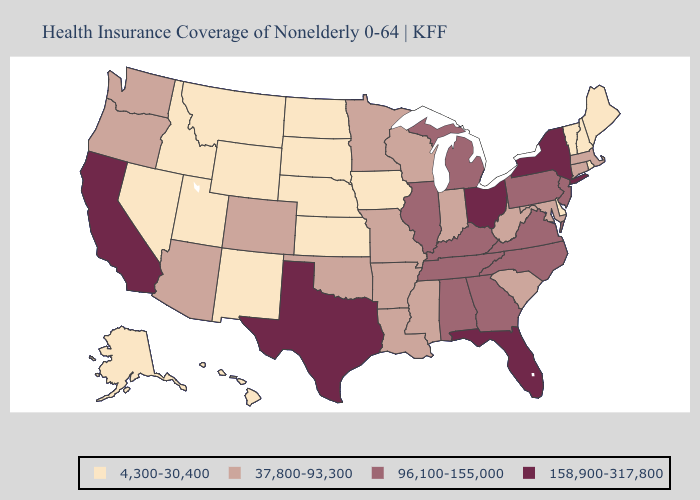Which states have the highest value in the USA?
Concise answer only. California, Florida, New York, Ohio, Texas. Which states have the highest value in the USA?
Keep it brief. California, Florida, New York, Ohio, Texas. What is the lowest value in states that border Minnesota?
Short answer required. 4,300-30,400. What is the lowest value in the Northeast?
Short answer required. 4,300-30,400. Name the states that have a value in the range 158,900-317,800?
Answer briefly. California, Florida, New York, Ohio, Texas. Does Arizona have the lowest value in the West?
Write a very short answer. No. Name the states that have a value in the range 37,800-93,300?
Concise answer only. Arizona, Arkansas, Colorado, Connecticut, Indiana, Louisiana, Maryland, Massachusetts, Minnesota, Mississippi, Missouri, Oklahoma, Oregon, South Carolina, Washington, West Virginia, Wisconsin. What is the value of Ohio?
Write a very short answer. 158,900-317,800. Does North Dakota have a higher value than New Hampshire?
Quick response, please. No. Does Iowa have the same value as Kansas?
Keep it brief. Yes. What is the value of Arizona?
Give a very brief answer. 37,800-93,300. What is the value of Hawaii?
Write a very short answer. 4,300-30,400. Name the states that have a value in the range 37,800-93,300?
Quick response, please. Arizona, Arkansas, Colorado, Connecticut, Indiana, Louisiana, Maryland, Massachusetts, Minnesota, Mississippi, Missouri, Oklahoma, Oregon, South Carolina, Washington, West Virginia, Wisconsin. Name the states that have a value in the range 4,300-30,400?
Keep it brief. Alaska, Delaware, Hawaii, Idaho, Iowa, Kansas, Maine, Montana, Nebraska, Nevada, New Hampshire, New Mexico, North Dakota, Rhode Island, South Dakota, Utah, Vermont, Wyoming. Name the states that have a value in the range 4,300-30,400?
Keep it brief. Alaska, Delaware, Hawaii, Idaho, Iowa, Kansas, Maine, Montana, Nebraska, Nevada, New Hampshire, New Mexico, North Dakota, Rhode Island, South Dakota, Utah, Vermont, Wyoming. 